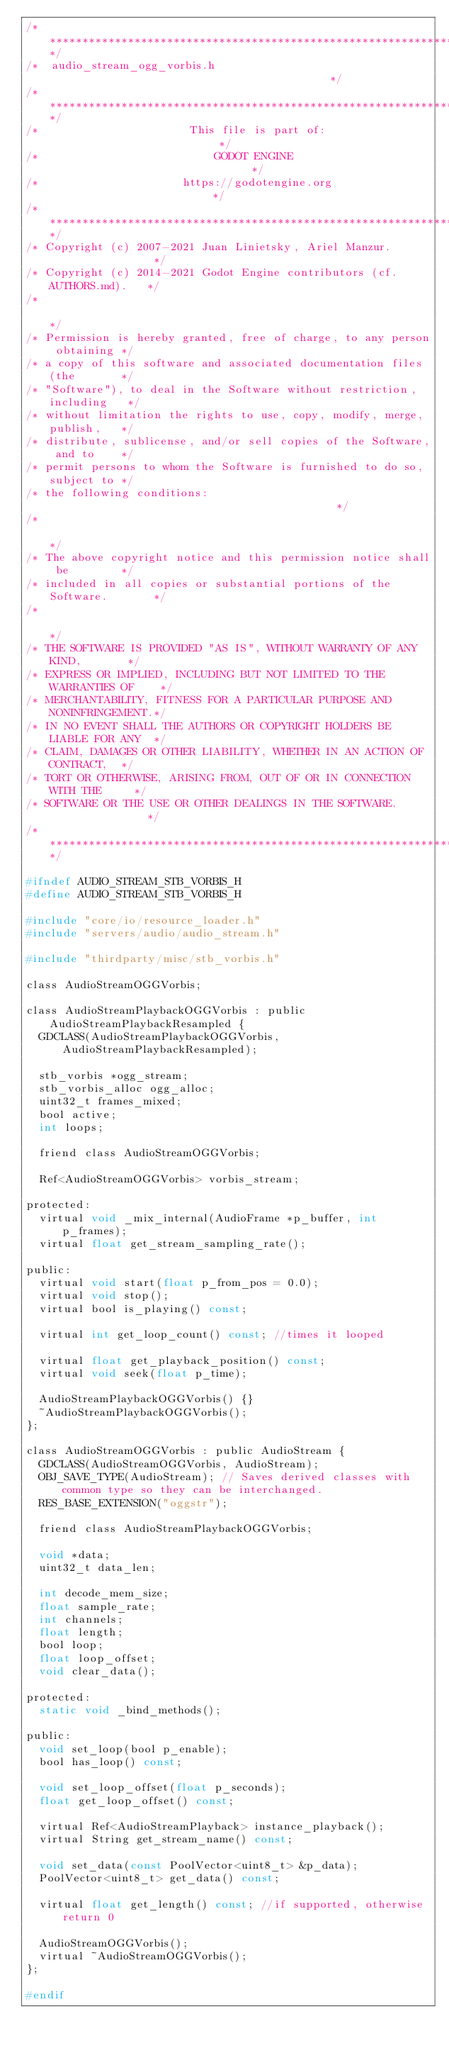<code> <loc_0><loc_0><loc_500><loc_500><_C_>/*************************************************************************/
/*  audio_stream_ogg_vorbis.h                                            */
/*************************************************************************/
/*                       This file is part of:                           */
/*                           GODOT ENGINE                                */
/*                      https://godotengine.org                          */
/*************************************************************************/
/* Copyright (c) 2007-2021 Juan Linietsky, Ariel Manzur.                 */
/* Copyright (c) 2014-2021 Godot Engine contributors (cf. AUTHORS.md).   */
/*                                                                       */
/* Permission is hereby granted, free of charge, to any person obtaining */
/* a copy of this software and associated documentation files (the       */
/* "Software"), to deal in the Software without restriction, including   */
/* without limitation the rights to use, copy, modify, merge, publish,   */
/* distribute, sublicense, and/or sell copies of the Software, and to    */
/* permit persons to whom the Software is furnished to do so, subject to */
/* the following conditions:                                             */
/*                                                                       */
/* The above copyright notice and this permission notice shall be        */
/* included in all copies or substantial portions of the Software.       */
/*                                                                       */
/* THE SOFTWARE IS PROVIDED "AS IS", WITHOUT WARRANTY OF ANY KIND,       */
/* EXPRESS OR IMPLIED, INCLUDING BUT NOT LIMITED TO THE WARRANTIES OF    */
/* MERCHANTABILITY, FITNESS FOR A PARTICULAR PURPOSE AND NONINFRINGEMENT.*/
/* IN NO EVENT SHALL THE AUTHORS OR COPYRIGHT HOLDERS BE LIABLE FOR ANY  */
/* CLAIM, DAMAGES OR OTHER LIABILITY, WHETHER IN AN ACTION OF CONTRACT,  */
/* TORT OR OTHERWISE, ARISING FROM, OUT OF OR IN CONNECTION WITH THE     */
/* SOFTWARE OR THE USE OR OTHER DEALINGS IN THE SOFTWARE.                */
/*************************************************************************/

#ifndef AUDIO_STREAM_STB_VORBIS_H
#define AUDIO_STREAM_STB_VORBIS_H

#include "core/io/resource_loader.h"
#include "servers/audio/audio_stream.h"

#include "thirdparty/misc/stb_vorbis.h"

class AudioStreamOGGVorbis;

class AudioStreamPlaybackOGGVorbis : public AudioStreamPlaybackResampled {
	GDCLASS(AudioStreamPlaybackOGGVorbis, AudioStreamPlaybackResampled);

	stb_vorbis *ogg_stream;
	stb_vorbis_alloc ogg_alloc;
	uint32_t frames_mixed;
	bool active;
	int loops;

	friend class AudioStreamOGGVorbis;

	Ref<AudioStreamOGGVorbis> vorbis_stream;

protected:
	virtual void _mix_internal(AudioFrame *p_buffer, int p_frames);
	virtual float get_stream_sampling_rate();

public:
	virtual void start(float p_from_pos = 0.0);
	virtual void stop();
	virtual bool is_playing() const;

	virtual int get_loop_count() const; //times it looped

	virtual float get_playback_position() const;
	virtual void seek(float p_time);

	AudioStreamPlaybackOGGVorbis() {}
	~AudioStreamPlaybackOGGVorbis();
};

class AudioStreamOGGVorbis : public AudioStream {
	GDCLASS(AudioStreamOGGVorbis, AudioStream);
	OBJ_SAVE_TYPE(AudioStream); // Saves derived classes with common type so they can be interchanged.
	RES_BASE_EXTENSION("oggstr");

	friend class AudioStreamPlaybackOGGVorbis;

	void *data;
	uint32_t data_len;

	int decode_mem_size;
	float sample_rate;
	int channels;
	float length;
	bool loop;
	float loop_offset;
	void clear_data();

protected:
	static void _bind_methods();

public:
	void set_loop(bool p_enable);
	bool has_loop() const;

	void set_loop_offset(float p_seconds);
	float get_loop_offset() const;

	virtual Ref<AudioStreamPlayback> instance_playback();
	virtual String get_stream_name() const;

	void set_data(const PoolVector<uint8_t> &p_data);
	PoolVector<uint8_t> get_data() const;

	virtual float get_length() const; //if supported, otherwise return 0

	AudioStreamOGGVorbis();
	virtual ~AudioStreamOGGVorbis();
};

#endif
</code> 